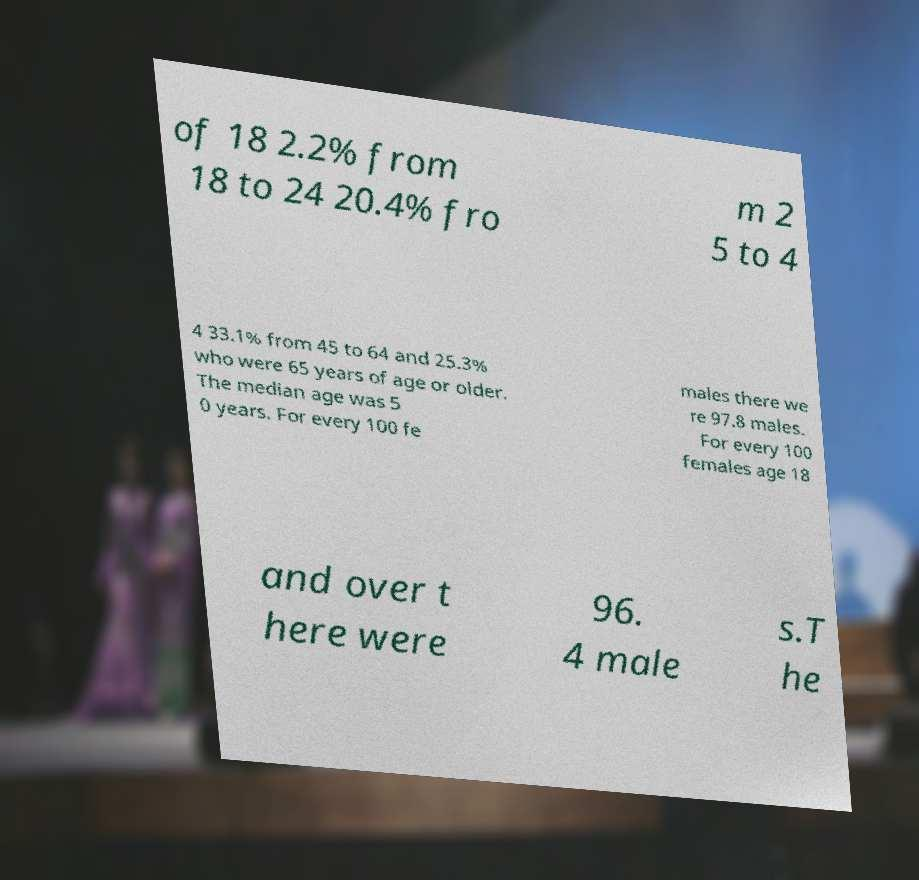I need the written content from this picture converted into text. Can you do that? of 18 2.2% from 18 to 24 20.4% fro m 2 5 to 4 4 33.1% from 45 to 64 and 25.3% who were 65 years of age or older. The median age was 5 0 years. For every 100 fe males there we re 97.8 males. For every 100 females age 18 and over t here were 96. 4 male s.T he 